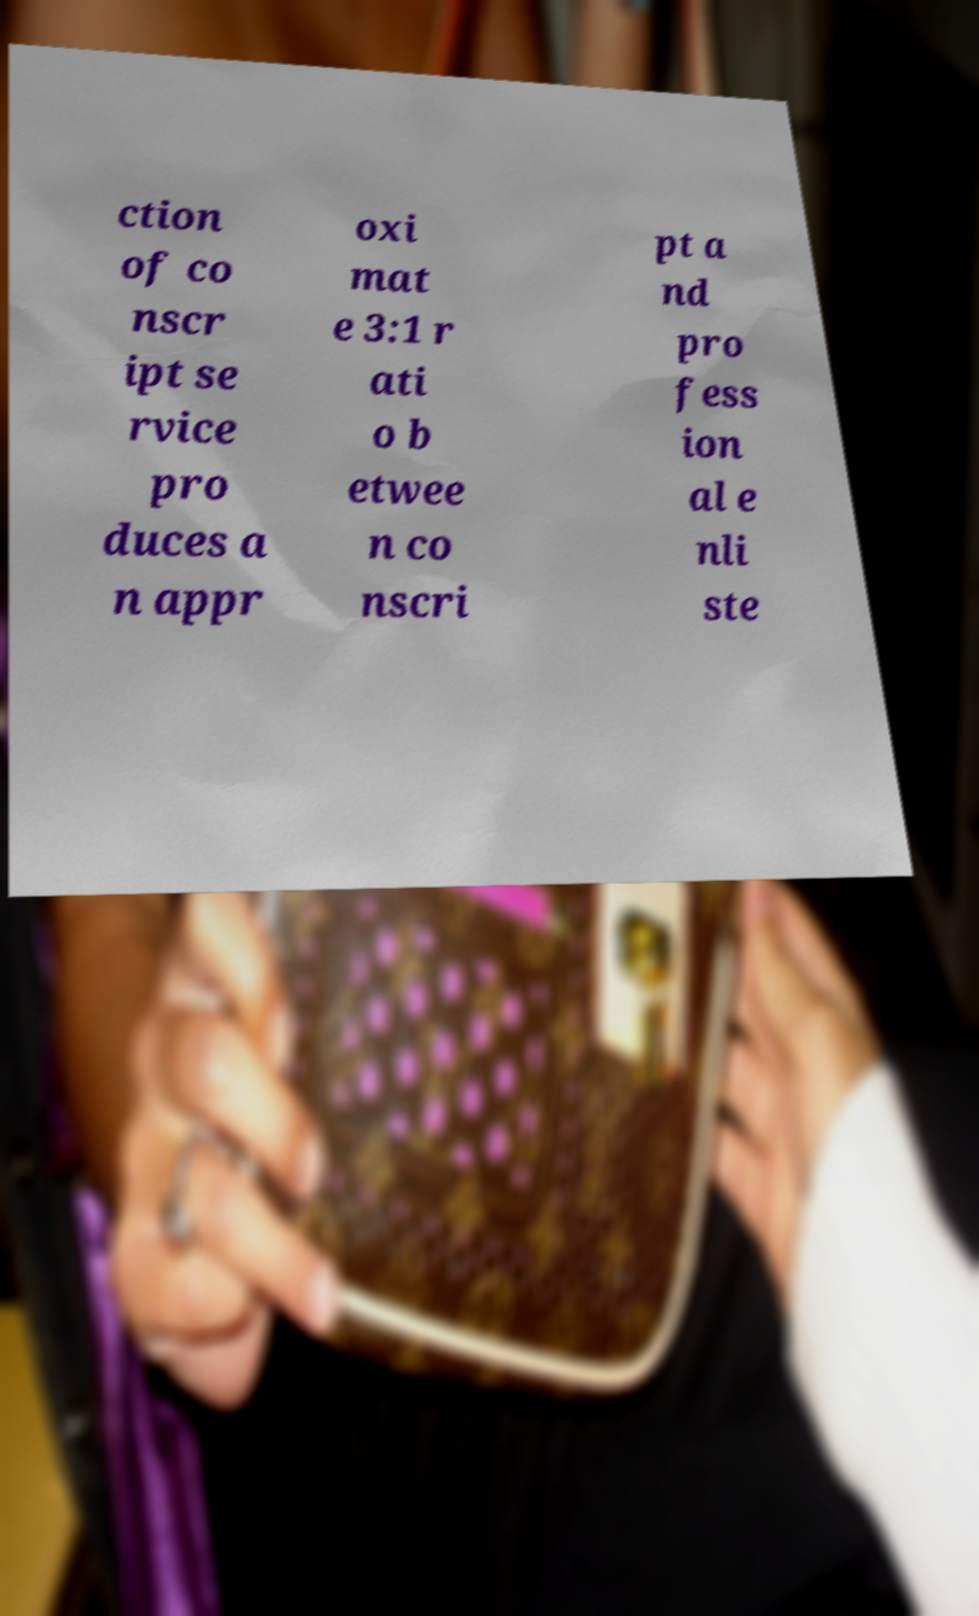For documentation purposes, I need the text within this image transcribed. Could you provide that? ction of co nscr ipt se rvice pro duces a n appr oxi mat e 3:1 r ati o b etwee n co nscri pt a nd pro fess ion al e nli ste 